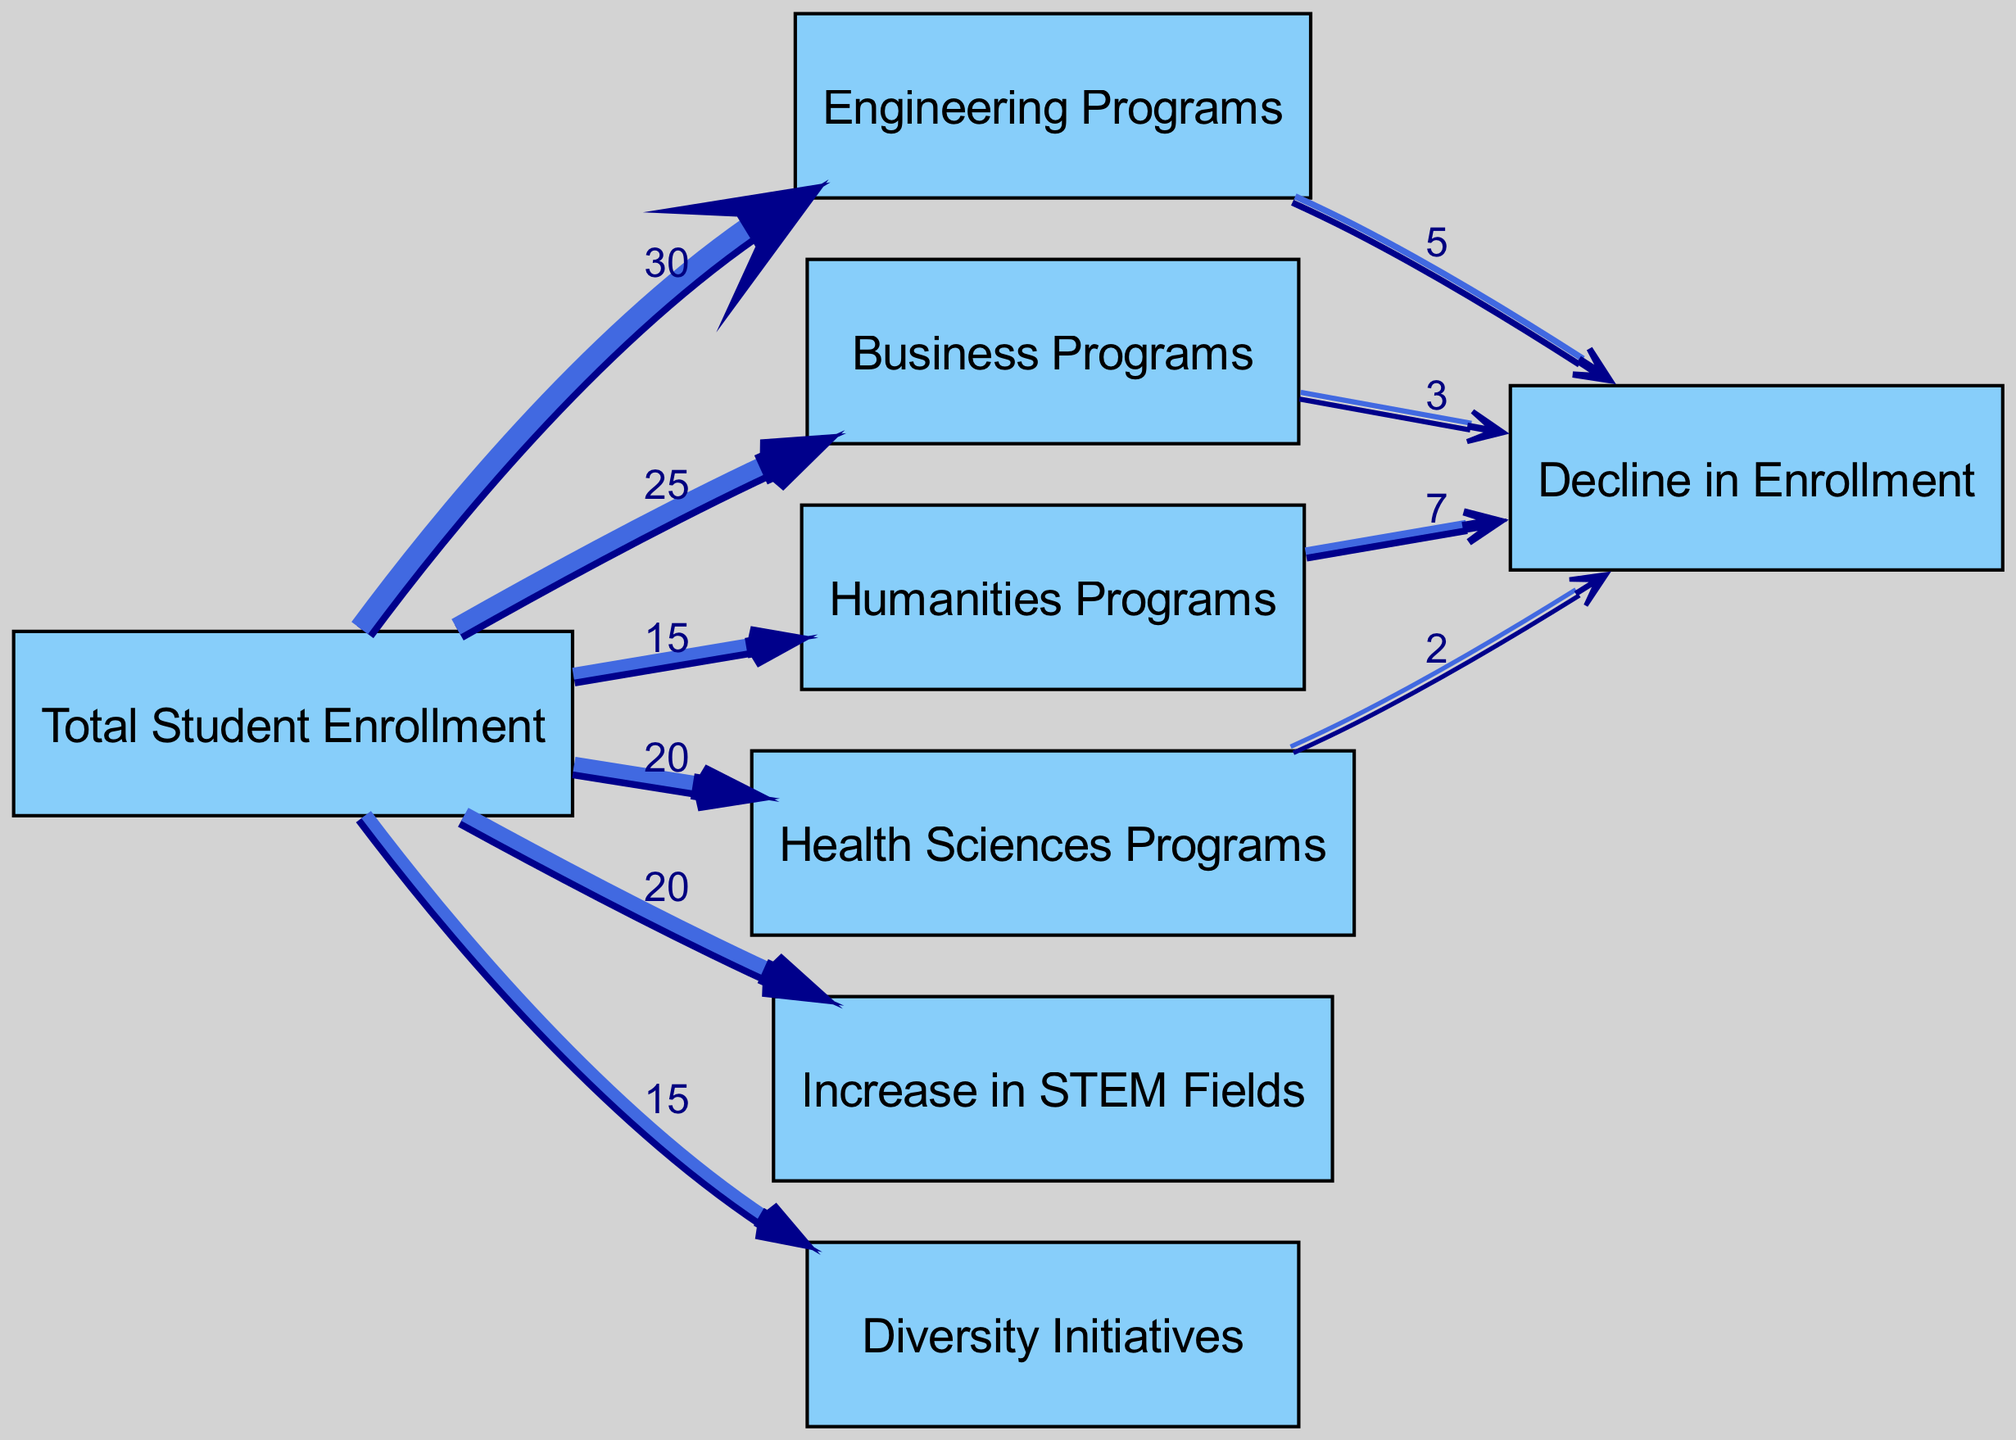What is the total student enrollment in Engineering Programs? The diagram shows that the Engineering Programs have a total student enrollment value of 30. This is directly indicated as a link from "Total Student Enrollment" to "Engineering Programs".
Answer: 30 What is the value of Decline in Enrollment for Humanities Programs? The link between "Humanities Programs" and "Decline in Enrollment" shows a value of 7, which indicates the number of students in this category experiencing a decline.
Answer: 7 How many programs have a decline in enrollment? The diagram shows four programs that have specific values linked to "Decline in Enrollment": Engineering, Business, Humanities, and Health Sciences. Thus, there are four programs.
Answer: 4 What source has the highest value in the flow? The highest source is "Total Student Enrollment" which has outflows to multiple programs, with the highest aggregated value of 100 (sum of all program enrollments) before any declines.
Answer: Total Student Enrollment What is the relationship between Total Student Enrollment and Diversity Initiatives? The flow from "Total Student Enrollment" to "Diversity Initiatives" is direct, showing a value of 15, indicating that a portion of total students is accounted for under diversity initiatives.
Answer: 15 What percentage of students in Engineering Programs experienced a decline in enrollment? The decline in Engineering Programs is 5, and the total enrollment in Engineering is 30. This means (5/30)*100 = 16.67%.
Answer: 16.67% How does the enrollment in STEM fields compare to the overall enrollment? The diagram indicates there were 20 students who enrolled in STEM fields out of the total enrollment, which represents about 20% of the total enrollment.
Answer: 20% What is the total enrollment in Health Sciences Programs? The link from "Total Student Enrollment" to "Health Sciences Programs" indicates the total enrollment in this category is 20.
Answer: 20 What proportion of students enrolled in Business Programs that are declining? The declining value for Business Programs is 3 out of 25 total enrolled in Business Programs, which gives a proportion of (3/25) = 0.12 or 12%.
Answer: 12% 